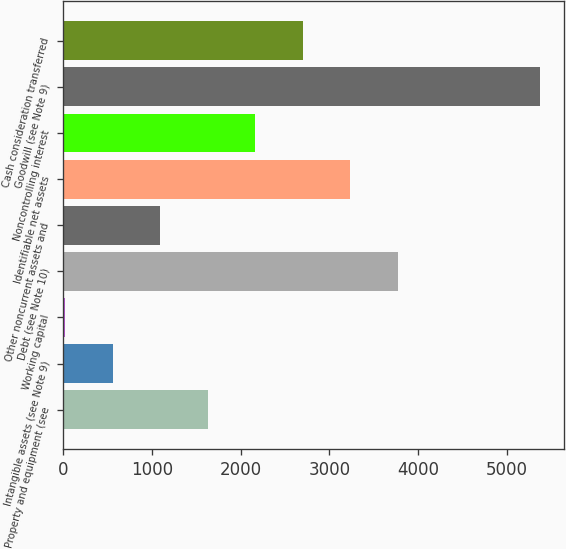Convert chart. <chart><loc_0><loc_0><loc_500><loc_500><bar_chart><fcel>Property and equipment (see<fcel>Intangible assets (see Note 9)<fcel>Working capital<fcel>Debt (see Note 10)<fcel>Other noncurrent assets and<fcel>Identifiable net assets<fcel>Noncontrolling interest<fcel>Goodwill (see Note 9)<fcel>Cash consideration transferred<nl><fcel>1628.7<fcel>558.9<fcel>24<fcel>3768.3<fcel>1093.8<fcel>3233.4<fcel>2163.6<fcel>5373<fcel>2698.5<nl></chart> 